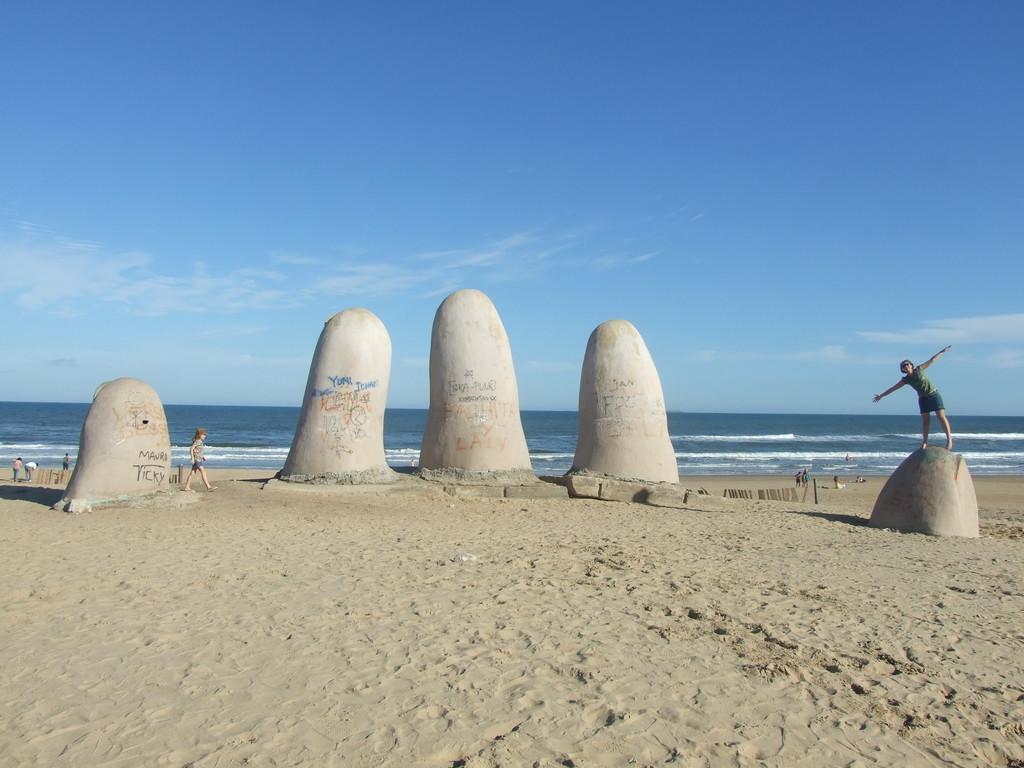Can you describe this image briefly? In this image we can see a few big stones, few people standing and walking on the sand, behind we can see water and a few clouds in the sky. 